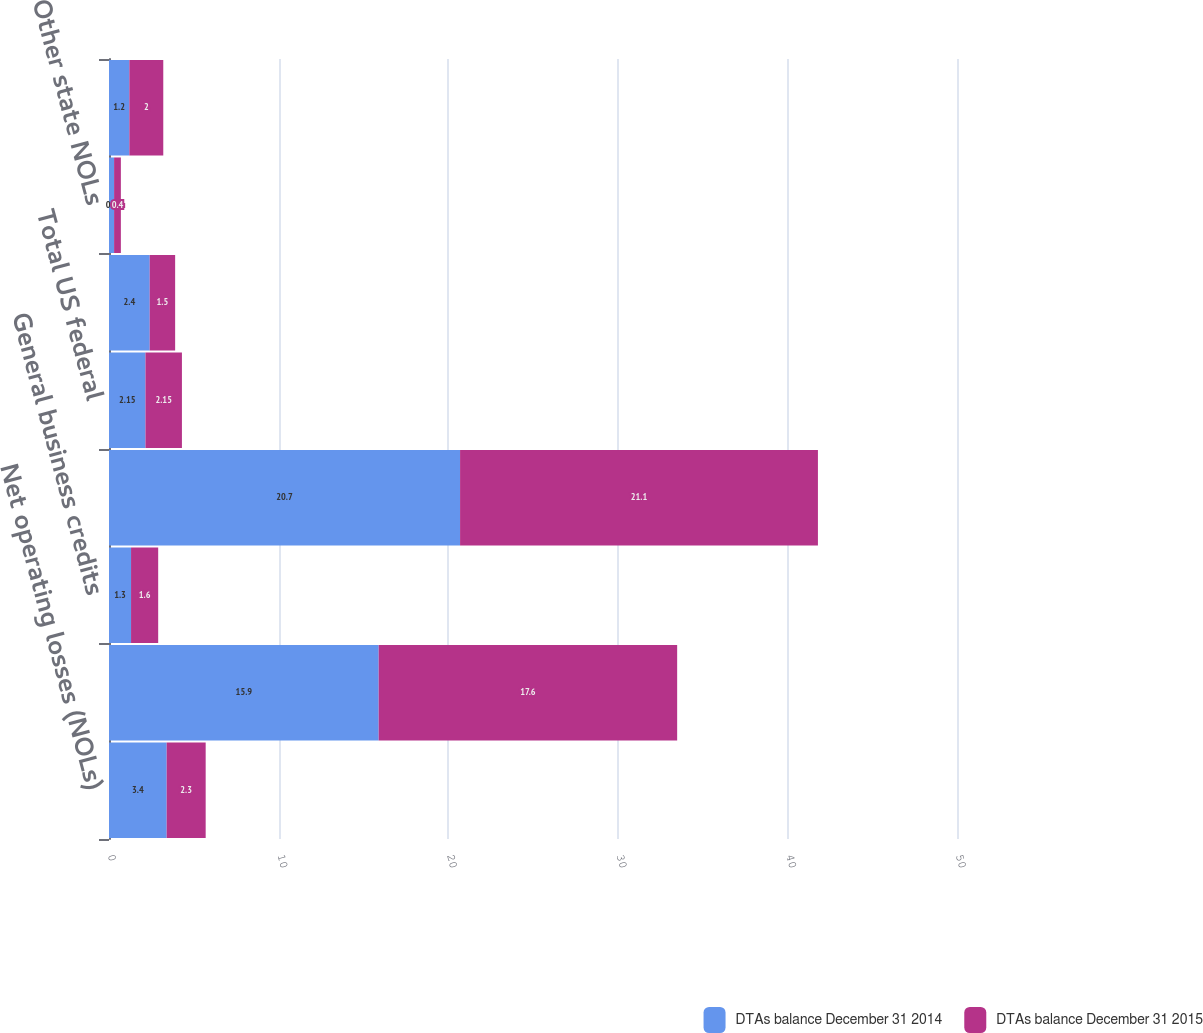<chart> <loc_0><loc_0><loc_500><loc_500><stacked_bar_chart><ecel><fcel>Net operating losses (NOLs)<fcel>Foreign tax credits (FTCs) (3)<fcel>General business credits<fcel>Future tax deductions and<fcel>Total US federal<fcel>New York NOLs<fcel>Other state NOLs<fcel>Future tax deductions<nl><fcel>DTAs balance December 31 2014<fcel>3.4<fcel>15.9<fcel>1.3<fcel>20.7<fcel>2.15<fcel>2.4<fcel>0.3<fcel>1.2<nl><fcel>DTAs balance December 31 2015<fcel>2.3<fcel>17.6<fcel>1.6<fcel>21.1<fcel>2.15<fcel>1.5<fcel>0.4<fcel>2<nl></chart> 